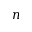<formula> <loc_0><loc_0><loc_500><loc_500>n</formula> 